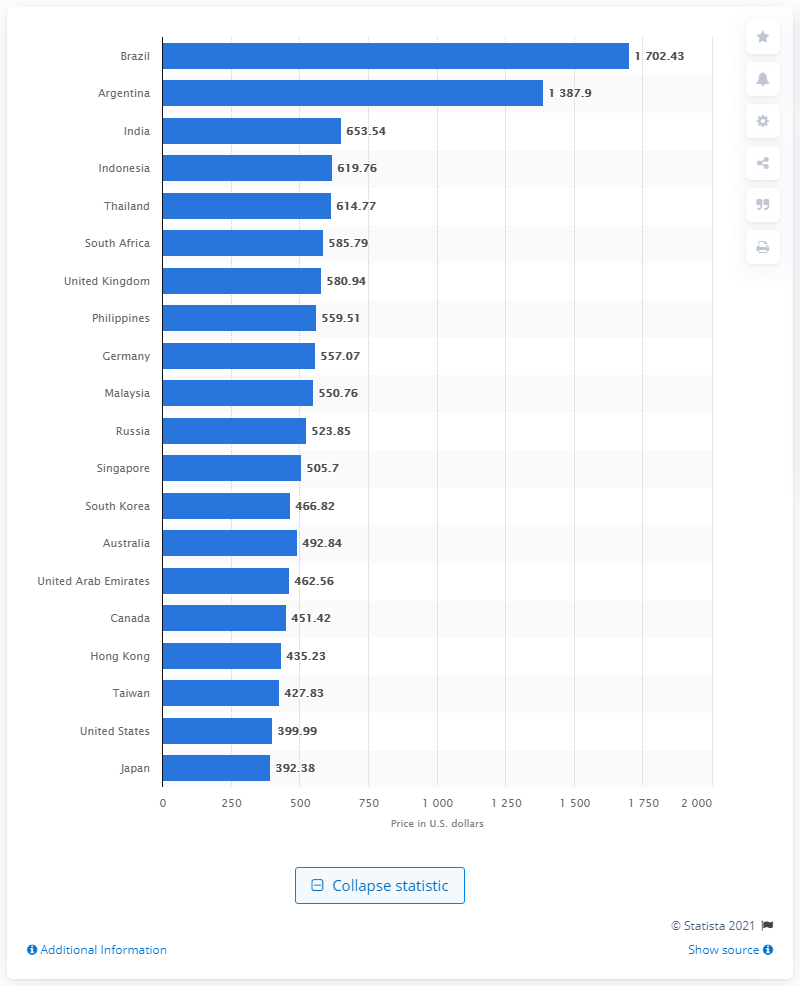Give some essential details in this illustration. Brazil ranked first with a suggested retail price of more than 1,702 U.S. dollars. 